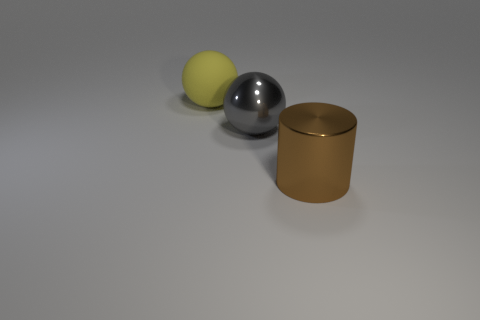What color is the large metallic ball?
Keep it short and to the point. Gray. What number of other things are the same size as the metal ball?
Make the answer very short. 2. What is the material of the other large object that is the same shape as the large gray object?
Make the answer very short. Rubber. There is a large sphere in front of the big sphere to the left of the big metallic thing left of the big brown object; what is its material?
Provide a short and direct response. Metal. What size is the ball that is made of the same material as the brown thing?
Provide a succinct answer. Large. Is there any other thing that has the same color as the cylinder?
Offer a terse response. No. There is a sphere in front of the large matte object; does it have the same color as the large metallic object to the right of the gray object?
Your response must be concise. No. There is a ball that is in front of the matte ball; what color is it?
Provide a succinct answer. Gray. Is the size of the metallic thing on the left side of the brown thing the same as the big brown thing?
Your answer should be compact. Yes. Is the number of purple shiny cylinders less than the number of brown metal cylinders?
Provide a succinct answer. Yes. 